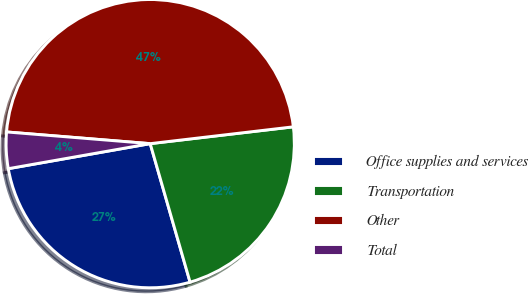<chart> <loc_0><loc_0><loc_500><loc_500><pie_chart><fcel>Office supplies and services<fcel>Transportation<fcel>Other<fcel>Total<nl><fcel>26.68%<fcel>22.4%<fcel>46.84%<fcel>4.07%<nl></chart> 